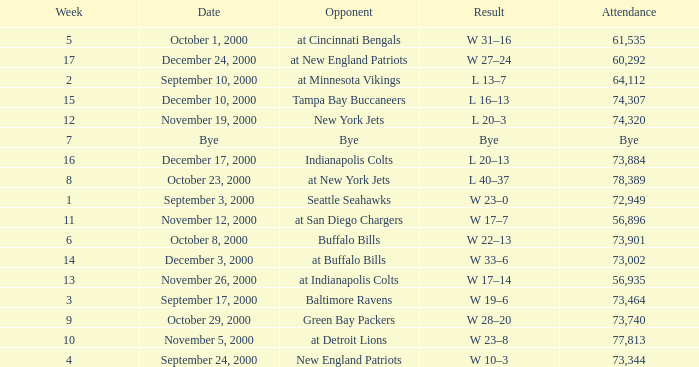What is the Attendance for a Week earlier than 16, and a Date of bye? Bye. 